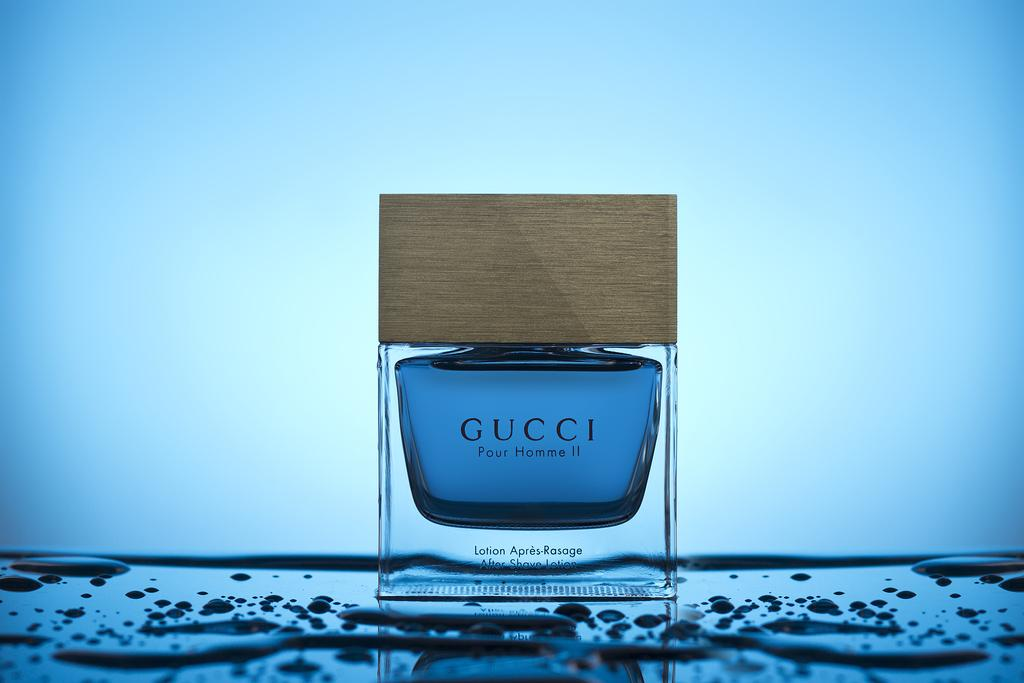<image>
Provide a brief description of the given image. A bottle of Gucci Pour Homme II perfume. 